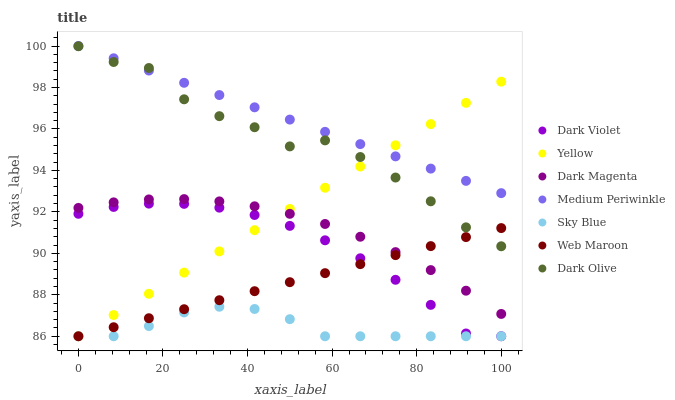Does Sky Blue have the minimum area under the curve?
Answer yes or no. Yes. Does Medium Periwinkle have the maximum area under the curve?
Answer yes or no. Yes. Does Dark Olive have the minimum area under the curve?
Answer yes or no. No. Does Dark Olive have the maximum area under the curve?
Answer yes or no. No. Is Web Maroon the smoothest?
Answer yes or no. Yes. Is Dark Olive the roughest?
Answer yes or no. Yes. Is Medium Periwinkle the smoothest?
Answer yes or no. No. Is Medium Periwinkle the roughest?
Answer yes or no. No. Does Web Maroon have the lowest value?
Answer yes or no. Yes. Does Dark Olive have the lowest value?
Answer yes or no. No. Does Medium Periwinkle have the highest value?
Answer yes or no. Yes. Does Dark Olive have the highest value?
Answer yes or no. No. Is Dark Violet less than Medium Periwinkle?
Answer yes or no. Yes. Is Dark Magenta greater than Sky Blue?
Answer yes or no. Yes. Does Yellow intersect Dark Magenta?
Answer yes or no. Yes. Is Yellow less than Dark Magenta?
Answer yes or no. No. Is Yellow greater than Dark Magenta?
Answer yes or no. No. Does Dark Violet intersect Medium Periwinkle?
Answer yes or no. No. 